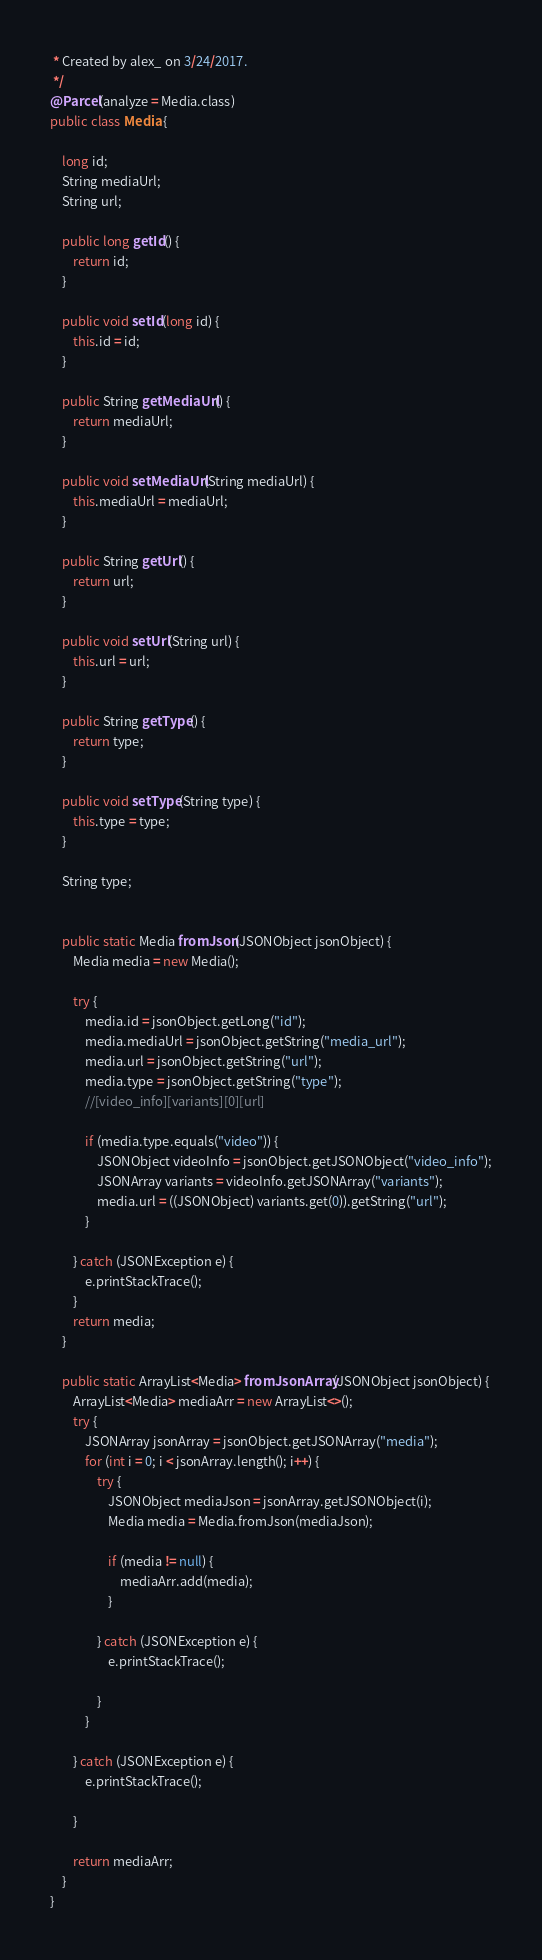<code> <loc_0><loc_0><loc_500><loc_500><_Java_> * Created by alex_ on 3/24/2017.
 */
@Parcel(analyze = Media.class)
public class Media {

    long id;
    String mediaUrl;
    String url;

    public long getId() {
        return id;
    }

    public void setId(long id) {
        this.id = id;
    }

    public String getMediaUrl() {
        return mediaUrl;
    }

    public void setMediaUrl(String mediaUrl) {
        this.mediaUrl = mediaUrl;
    }

    public String getUrl() {
        return url;
    }

    public void setUrl(String url) {
        this.url = url;
    }

    public String getType() {
        return type;
    }

    public void setType(String type) {
        this.type = type;
    }

    String type;


    public static Media fromJson(JSONObject jsonObject) {
        Media media = new Media();

        try {
            media.id = jsonObject.getLong("id");
            media.mediaUrl = jsonObject.getString("media_url");
            media.url = jsonObject.getString("url");
            media.type = jsonObject.getString("type");
            //[video_info][variants][0][url]

            if (media.type.equals("video")) {
                JSONObject videoInfo = jsonObject.getJSONObject("video_info");
                JSONArray variants = videoInfo.getJSONArray("variants");
                media.url = ((JSONObject) variants.get(0)).getString("url");
            }

        } catch (JSONException e) {
            e.printStackTrace();
        }
        return media;
    }

    public static ArrayList<Media> fromJsonArray(JSONObject jsonObject) {
        ArrayList<Media> mediaArr = new ArrayList<>();
        try {
            JSONArray jsonArray = jsonObject.getJSONArray("media");
            for (int i = 0; i < jsonArray.length(); i++) {
                try {
                    JSONObject mediaJson = jsonArray.getJSONObject(i);
                    Media media = Media.fromJson(mediaJson);

                    if (media != null) {
                        mediaArr.add(media);
                    }

                } catch (JSONException e) {
                    e.printStackTrace();

                }
            }

        } catch (JSONException e) {
            e.printStackTrace();

        }

        return mediaArr;
    }
}


</code> 